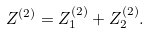<formula> <loc_0><loc_0><loc_500><loc_500>Z ^ { ( 2 ) } = Z _ { 1 } ^ { ( 2 ) } + Z _ { 2 } ^ { ( 2 ) } .</formula> 